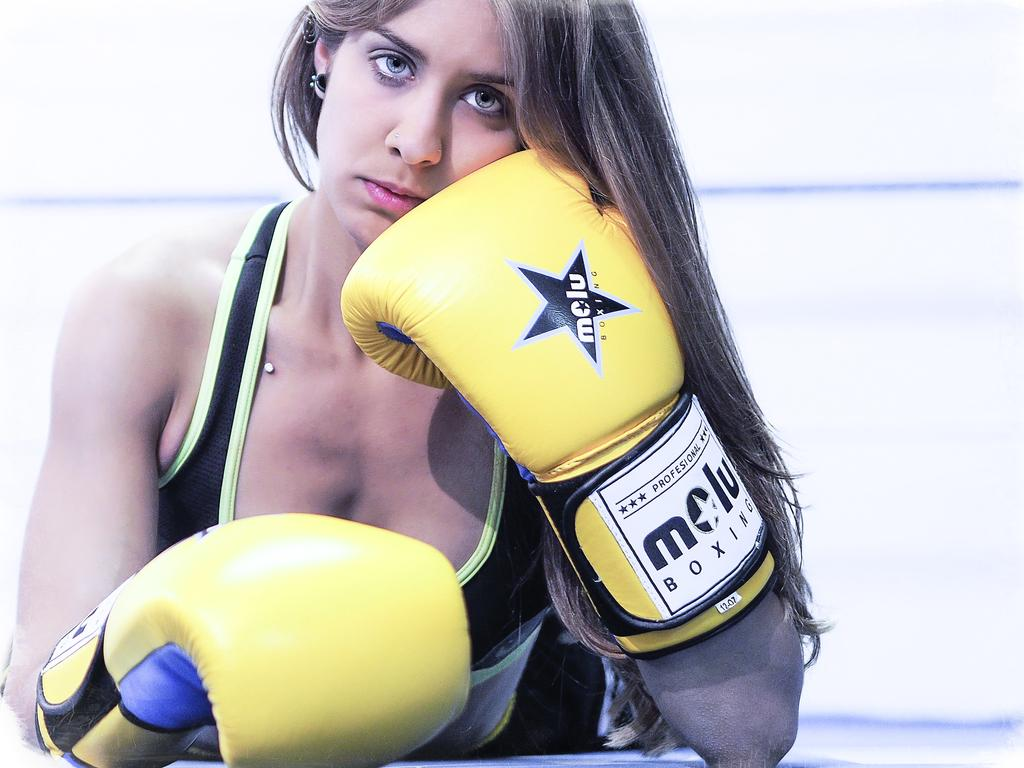Who is the main subject in the image? There is a woman in the image. What is the woman wearing on her hands? The woman is wearing boxing gloves. What is the woman's position in the image? The woman is laying on a path. What color is the background of the image? The background of the image is white. What type of honey is the woman using to train in the image? There is no honey present in the image, and the woman is not training with any honey. 